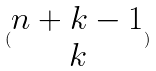<formula> <loc_0><loc_0><loc_500><loc_500>( \begin{matrix} n + k - 1 \\ k \end{matrix} )</formula> 